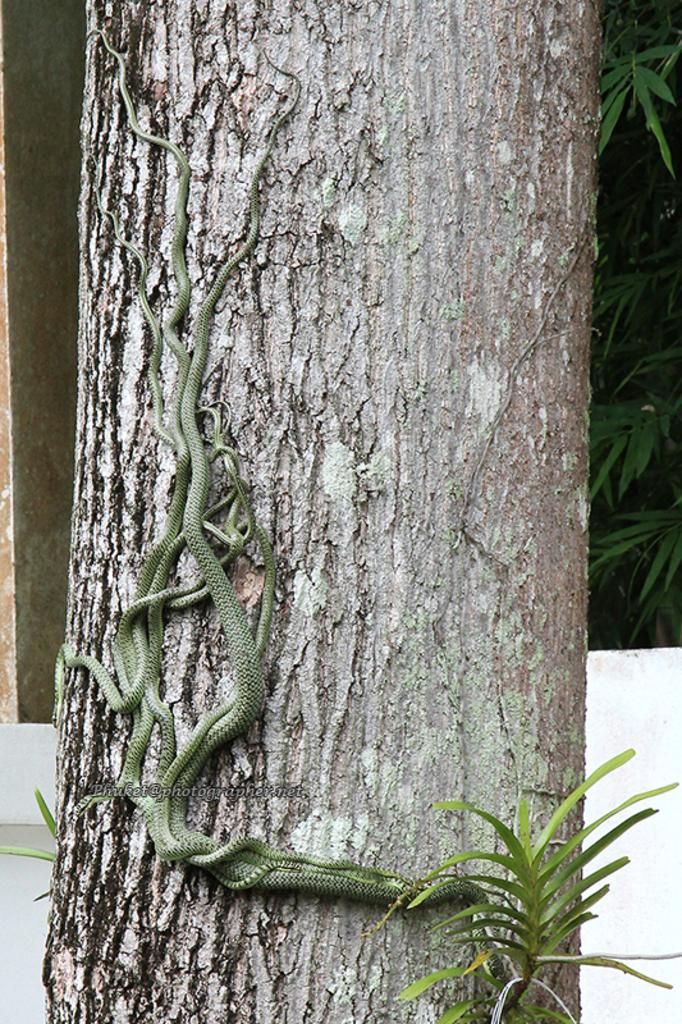What reason do the boys have for crossing the boundary in the image? There is no image provided, and therefore no boys or boundaries can be observed. 